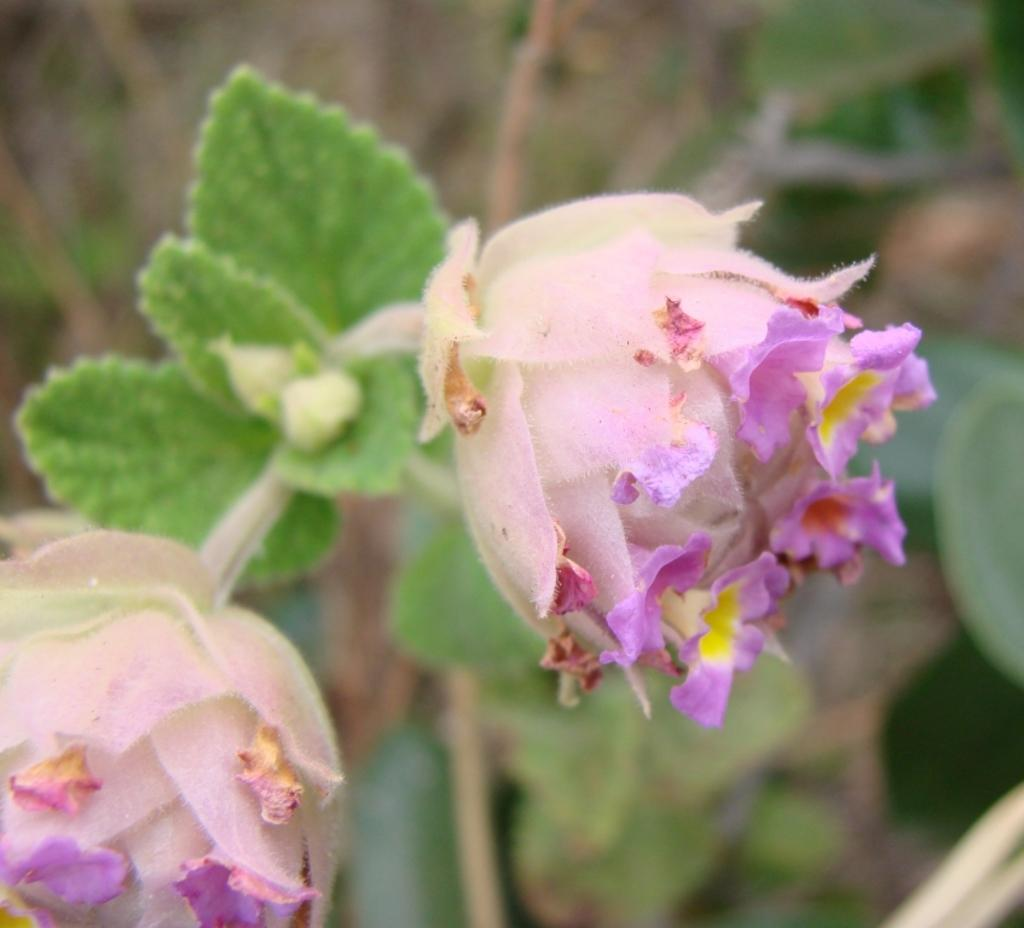How many flowers are in the image? There are two flowers in the image. What colors are the flowers? One flower is pink, and the other is purple. What other features do the flowers have? The flowers have green leaves. What else can be seen at the bottom of the image? There are plants at the bottom of the image. How would you describe the background of the image? The background of the image is blurred. What type of cork is being used to hold the flowers in the image? There is no cork present in the image; the flowers are not being held by any visible support. 